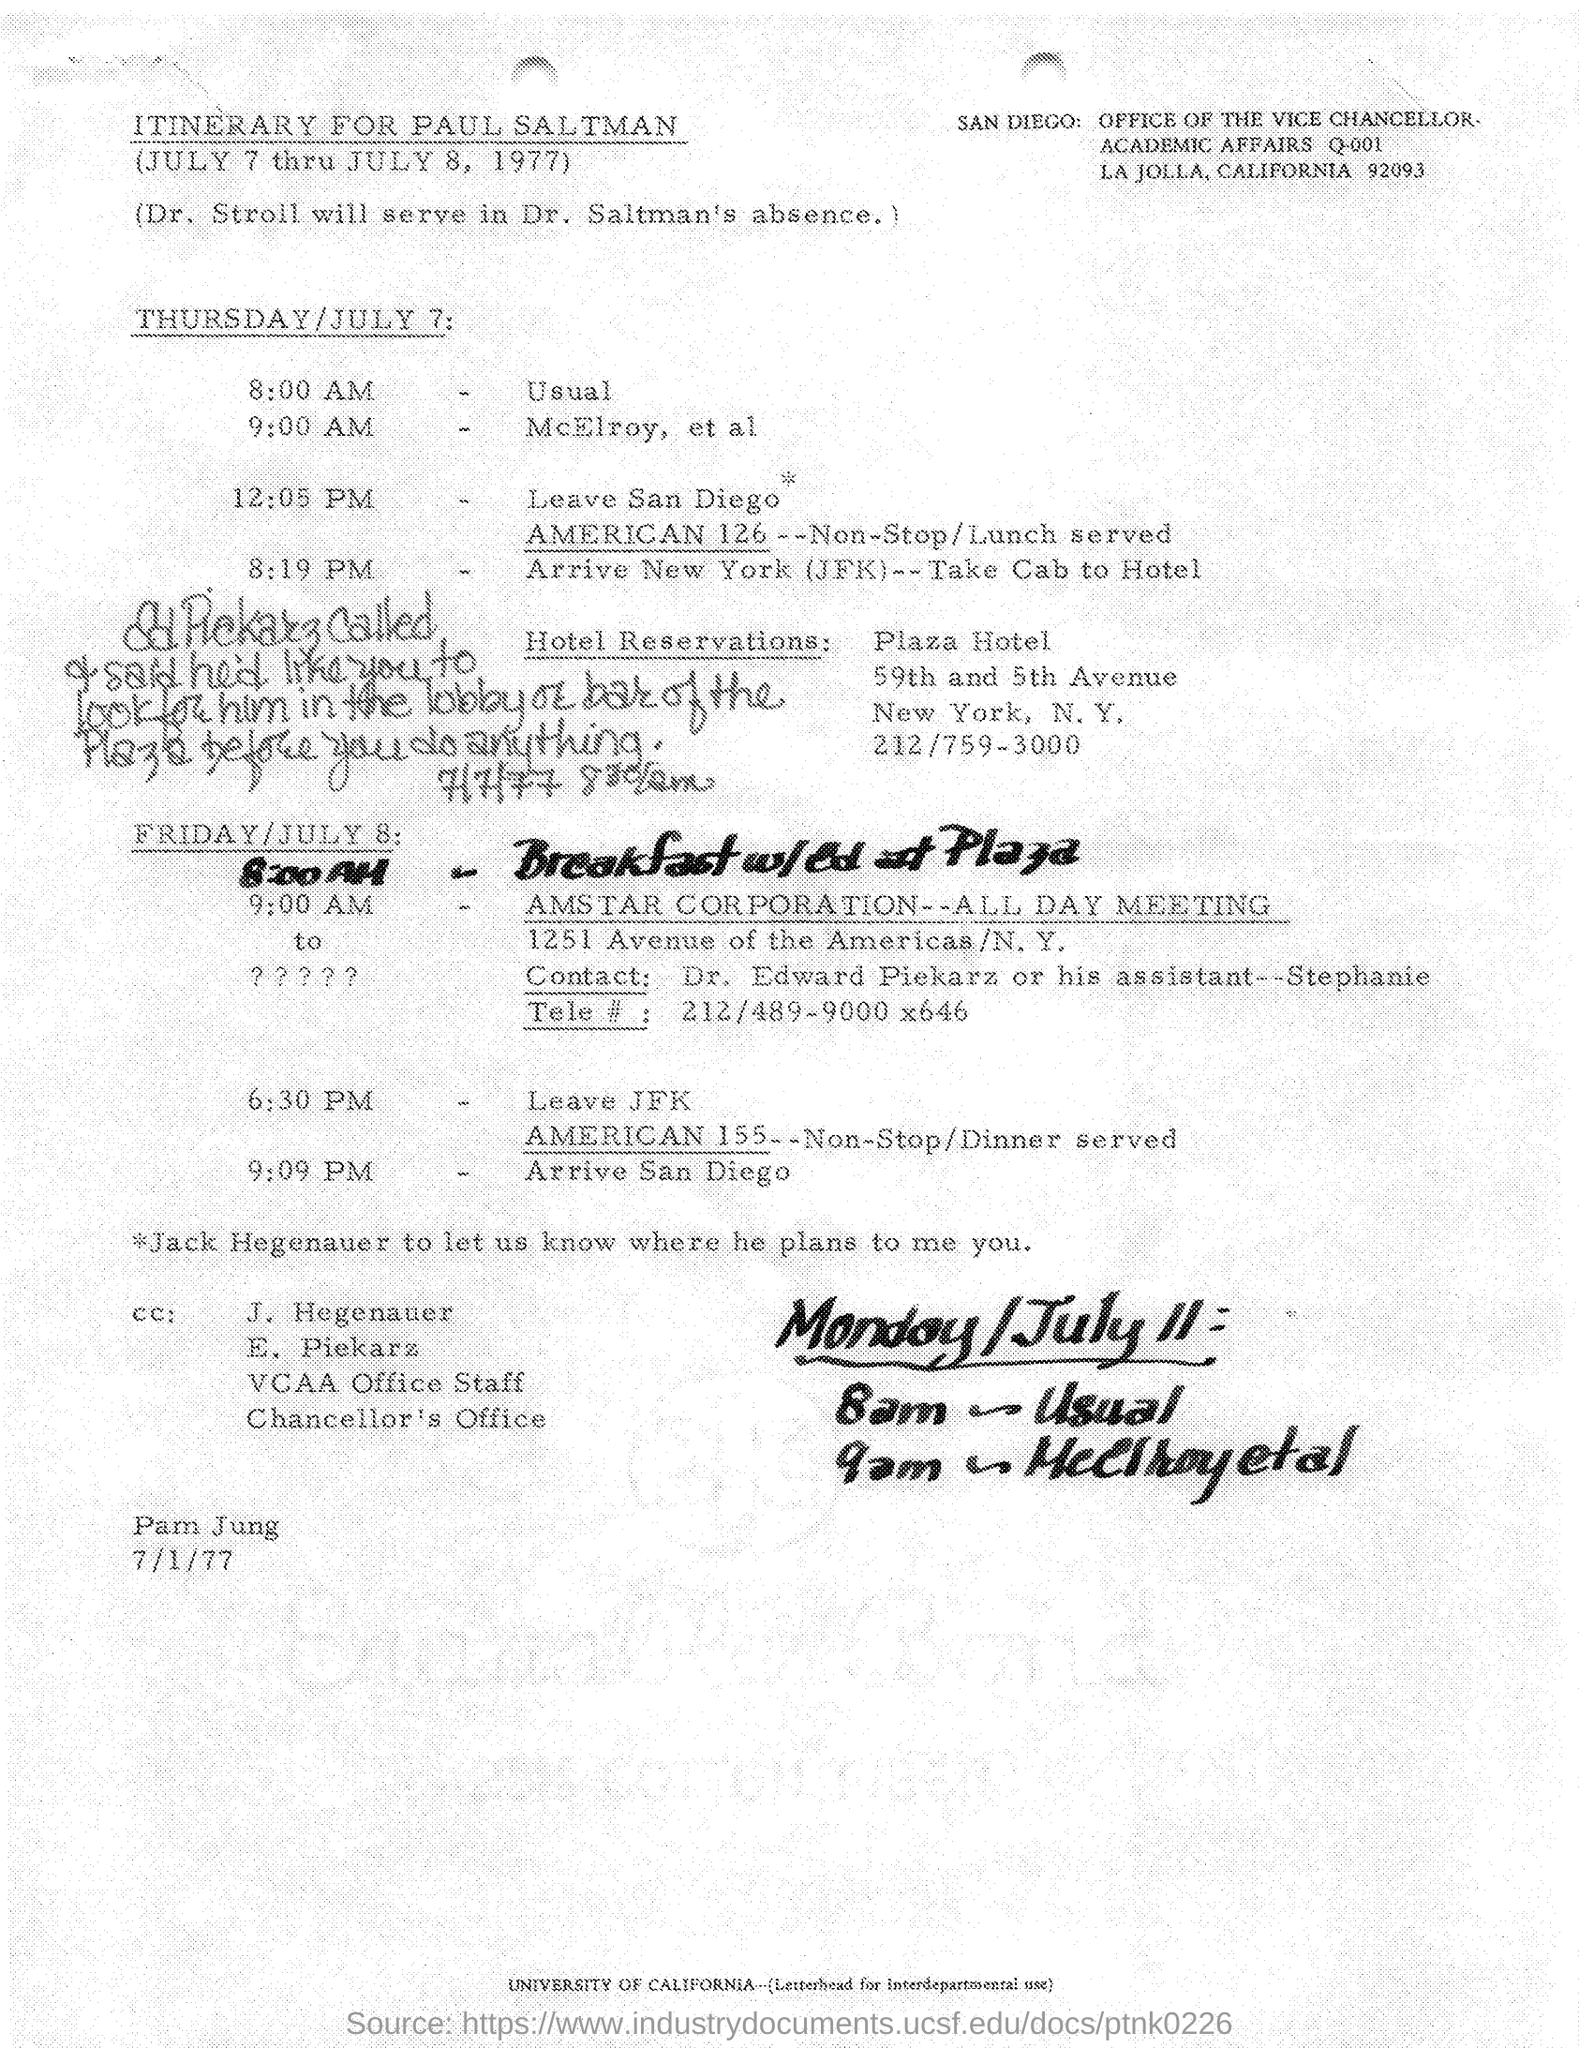Who's itinerary is this ?
Your response must be concise. Paul Saltman. Which university is specified in the document at the bottom ?
Offer a very short reply. UNIVERSITY OF CALIFORNIA. 